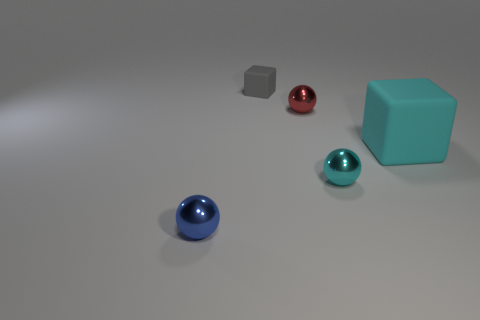Is the ball that is on the left side of the small gray rubber thing made of the same material as the sphere that is behind the big cyan matte thing?
Your answer should be compact. Yes. How many large cyan things are the same material as the tiny blue sphere?
Your answer should be very brief. 0. The tiny rubber cube is what color?
Your response must be concise. Gray. There is a rubber thing behind the large cube; is its shape the same as the tiny shiny object that is behind the large rubber thing?
Make the answer very short. No. The matte block on the right side of the gray rubber object is what color?
Make the answer very short. Cyan. Are there fewer small blue objects that are right of the tiny red sphere than large cyan rubber objects to the right of the big cyan rubber cube?
Give a very brief answer. No. What number of other objects are there of the same material as the big cyan object?
Your response must be concise. 1. Is the big thing made of the same material as the red sphere?
Offer a terse response. No. How many other things are there of the same size as the cyan rubber block?
Your response must be concise. 0. There is a ball left of the block that is behind the tiny red ball; how big is it?
Ensure brevity in your answer.  Small. 